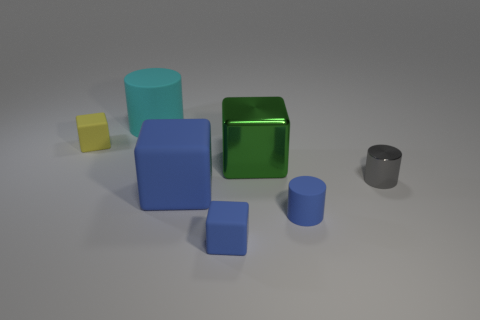How many things are either matte cubes that are in front of the metallic block or tiny objects that are on the right side of the small yellow thing?
Keep it short and to the point. 4. There is a cube on the left side of the matte object that is behind the yellow rubber cube; what is it made of?
Provide a short and direct response. Rubber. How many other objects are there of the same material as the large cyan cylinder?
Keep it short and to the point. 4. Does the large shiny thing have the same shape as the tiny gray object?
Your answer should be compact. No. There is a shiny object that is on the right side of the big green thing; how big is it?
Provide a succinct answer. Small. Does the cyan matte cylinder have the same size as the rubber cube behind the gray metallic cylinder?
Offer a terse response. No. Is the number of small yellow things that are on the right side of the big cyan rubber thing less than the number of small purple blocks?
Ensure brevity in your answer.  No. There is a blue object that is the same shape as the big cyan thing; what is it made of?
Give a very brief answer. Rubber. The tiny object that is left of the gray object and behind the large matte block has what shape?
Provide a succinct answer. Cube. What shape is the other big object that is made of the same material as the cyan thing?
Offer a very short reply. Cube. 